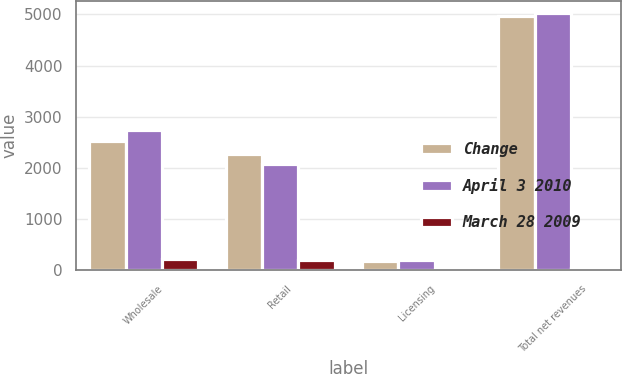<chart> <loc_0><loc_0><loc_500><loc_500><stacked_bar_chart><ecel><fcel>Wholesale<fcel>Retail<fcel>Licensing<fcel>Total net revenues<nl><fcel>Change<fcel>2532.4<fcel>2263.1<fcel>183.4<fcel>4978.9<nl><fcel>April 3 2010<fcel>2749.5<fcel>2074.2<fcel>195.2<fcel>5018.9<nl><fcel>March 28 2009<fcel>217.1<fcel>188.9<fcel>11.8<fcel>40<nl></chart> 